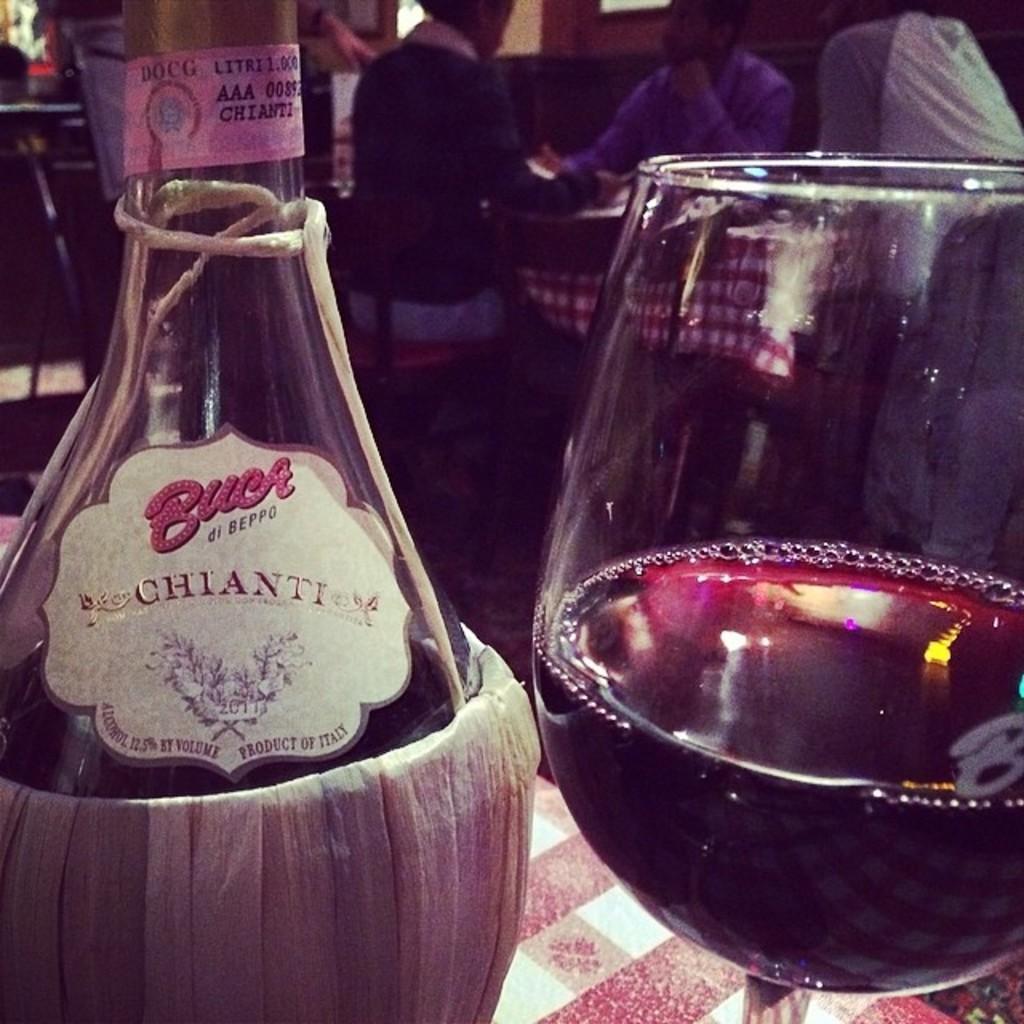Describe this image in one or two sentences. In this image i can see a bottle and a glass. 